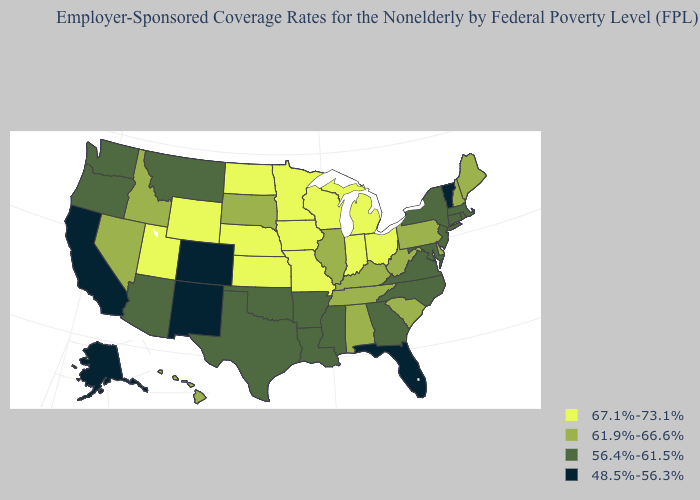Name the states that have a value in the range 56.4%-61.5%?
Write a very short answer. Arizona, Arkansas, Connecticut, Georgia, Louisiana, Maryland, Massachusetts, Mississippi, Montana, New Jersey, New York, North Carolina, Oklahoma, Oregon, Rhode Island, Texas, Virginia, Washington. What is the highest value in states that border Texas?
Quick response, please. 56.4%-61.5%. Which states have the lowest value in the USA?
Answer briefly. Alaska, California, Colorado, Florida, New Mexico, Vermont. Among the states that border Oklahoma , does New Mexico have the lowest value?
Answer briefly. Yes. Name the states that have a value in the range 56.4%-61.5%?
Answer briefly. Arizona, Arkansas, Connecticut, Georgia, Louisiana, Maryland, Massachusetts, Mississippi, Montana, New Jersey, New York, North Carolina, Oklahoma, Oregon, Rhode Island, Texas, Virginia, Washington. Which states have the lowest value in the South?
Be succinct. Florida. Which states have the lowest value in the MidWest?
Be succinct. Illinois, South Dakota. Among the states that border Wyoming , does Idaho have the lowest value?
Short answer required. No. What is the value of Kansas?
Keep it brief. 67.1%-73.1%. What is the value of Montana?
Concise answer only. 56.4%-61.5%. What is the value of Rhode Island?
Quick response, please. 56.4%-61.5%. What is the value of Arizona?
Quick response, please. 56.4%-61.5%. What is the value of Connecticut?
Write a very short answer. 56.4%-61.5%. What is the highest value in the Northeast ?
Quick response, please. 61.9%-66.6%. Name the states that have a value in the range 67.1%-73.1%?
Give a very brief answer. Indiana, Iowa, Kansas, Michigan, Minnesota, Missouri, Nebraska, North Dakota, Ohio, Utah, Wisconsin, Wyoming. 